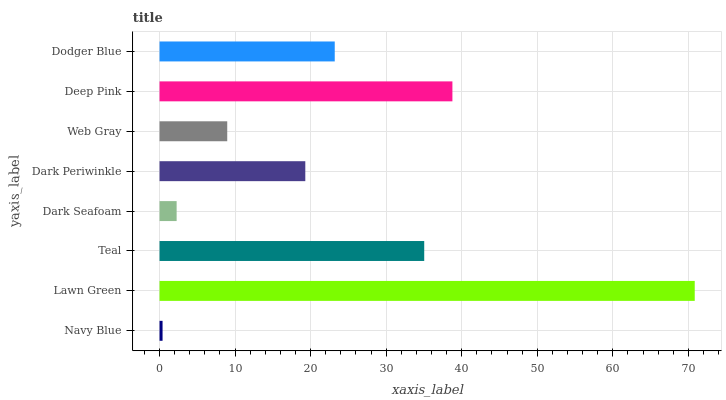Is Navy Blue the minimum?
Answer yes or no. Yes. Is Lawn Green the maximum?
Answer yes or no. Yes. Is Teal the minimum?
Answer yes or no. No. Is Teal the maximum?
Answer yes or no. No. Is Lawn Green greater than Teal?
Answer yes or no. Yes. Is Teal less than Lawn Green?
Answer yes or no. Yes. Is Teal greater than Lawn Green?
Answer yes or no. No. Is Lawn Green less than Teal?
Answer yes or no. No. Is Dodger Blue the high median?
Answer yes or no. Yes. Is Dark Periwinkle the low median?
Answer yes or no. Yes. Is Dark Periwinkle the high median?
Answer yes or no. No. Is Dodger Blue the low median?
Answer yes or no. No. 